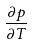<formula> <loc_0><loc_0><loc_500><loc_500>\frac { \partial p } { \partial T }</formula> 